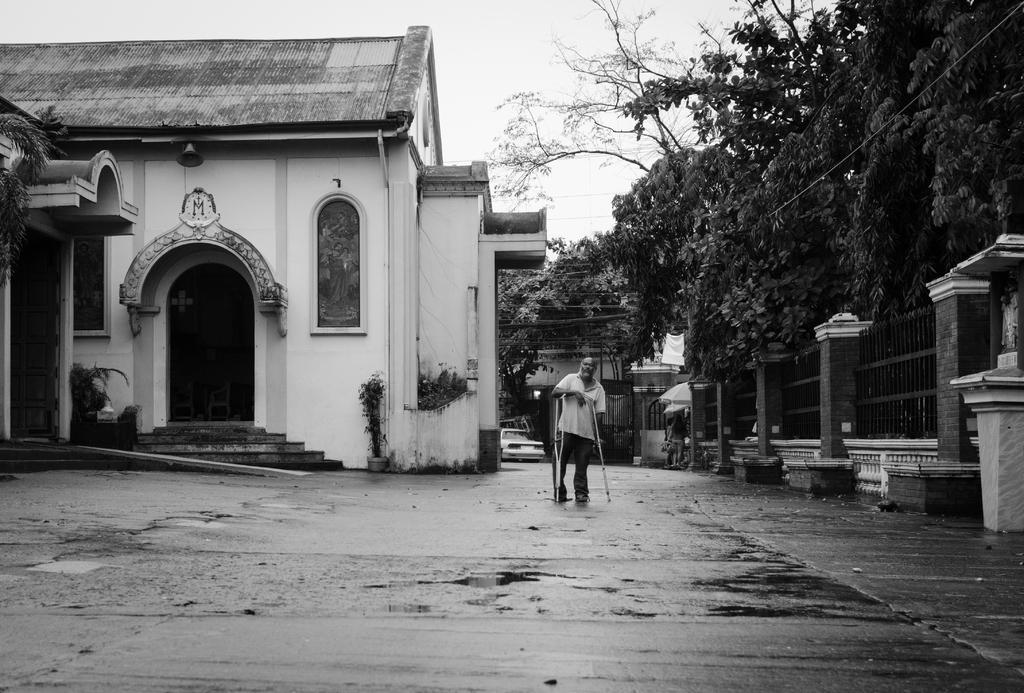Could you give a brief overview of what you see in this image? In this black and white image there is a person holding walking sticks in his hands and there is railing on the right side. There are trees, houses structure and sky in the background area. 